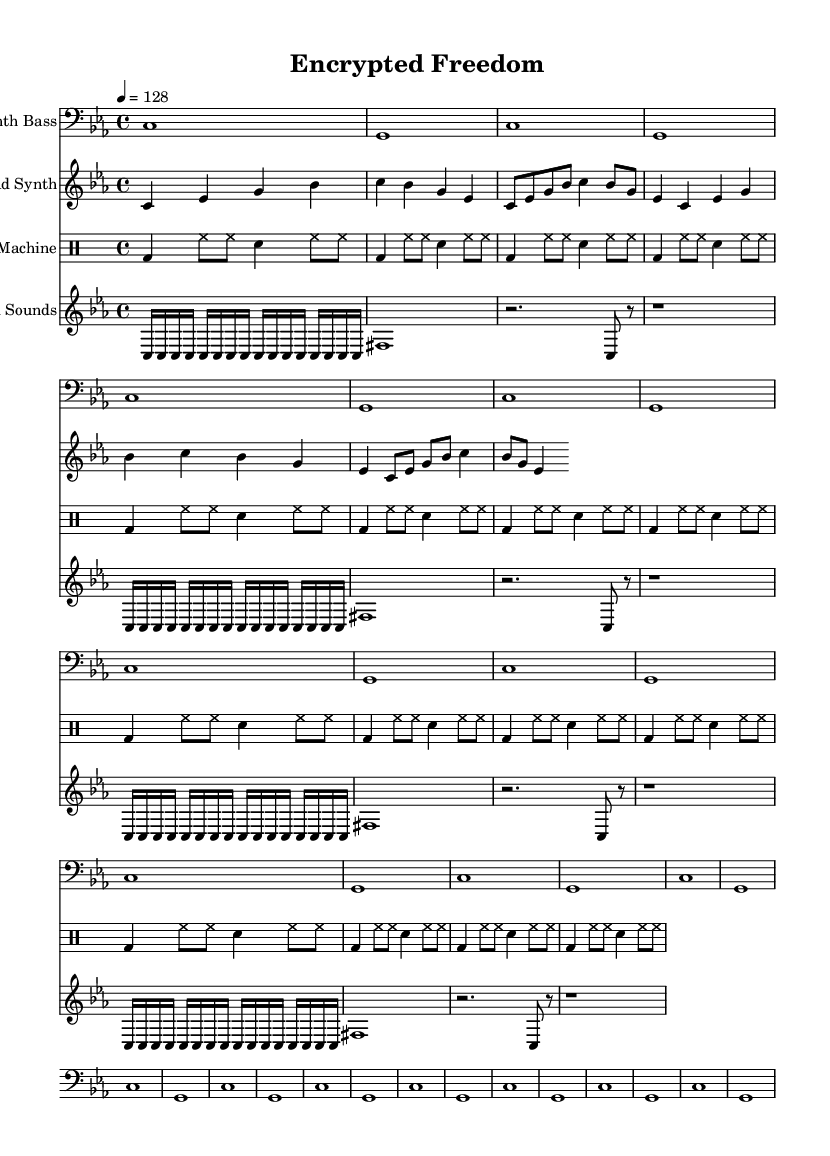What is the key signature of this music? The key signature is C minor, which has three flats (B flat, E flat, and A flat). This is indicated at the beginning of the staff.
Answer: C minor What is the time signature of this music? The time signature is 4/4, which means there are four beats in each measure and the quarter note gets one beat. This is shown at the beginning of the score.
Answer: 4/4 What is the tempo of this piece? The tempo marking indicates 128 beats per minute, as seen in the tempo directive. This means the music is intended to be played fairly briskly.
Answer: 128 How many measures does the Lead Synth part contain? To determine the number of measures, count the repetitions indicated in the lead synth part: there are 2 measures repeated twice, resulting in a total of 4 measures.
Answer: 4 What type of sounds are incorporated in the sampled sounds staff? The sampled sounds include a mix of repeated C notes and a F sharp, along with rests. This combination suggests the use of sounds reminiscent of surveillance equipment or encrypted messages.
Answer: C and F sharp What is the role of the drum machine in this piece? The drum machine provides a consistent rhythmic foundation with bass drums, hi-hats, and snare sounds, which is characteristic of dance music, enhancing the overall drive of the track.
Answer: Rhythmic foundation How do the sampled sounds contribute to the theme of the piece? The sampled sounds evoke the feel of surveillance through electronic sounds, combined with cargo of continuous notes, which ties into the overarching theme of encryption and freedom within a tech-driven context.
Answer: Evoke surveillance 